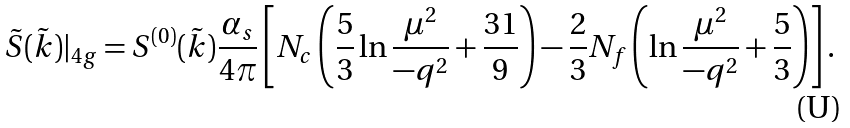<formula> <loc_0><loc_0><loc_500><loc_500>\tilde { S } ( \tilde { k } ) | _ { 4 g } = S ^ { ( 0 ) } ( \tilde { k } ) \frac { \alpha _ { s } } { 4 \pi } \left [ N _ { c } \left ( \frac { 5 } { 3 } \ln \frac { \mu ^ { 2 } } { - q ^ { 2 } } + \frac { 3 1 } { 9 } \right ) - \frac { 2 } { 3 } N _ { f } \left ( \ln \frac { \mu ^ { 2 } } { - q ^ { 2 } } + \frac { 5 } { 3 } \right ) \right ] .</formula> 